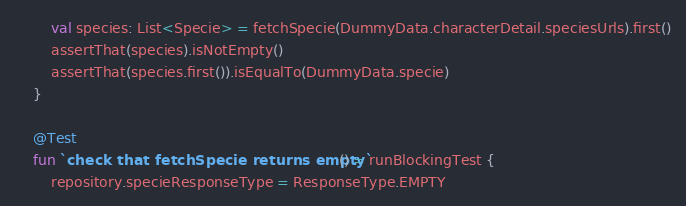<code> <loc_0><loc_0><loc_500><loc_500><_Kotlin_>        val species: List<Specie> = fetchSpecie(DummyData.characterDetail.speciesUrls).first()
        assertThat(species).isNotEmpty()
        assertThat(species.first()).isEqualTo(DummyData.specie)
    }

    @Test
    fun `check that fetchSpecie returns empty`() = runBlockingTest {
        repository.specieResponseType = ResponseType.EMPTY</code> 